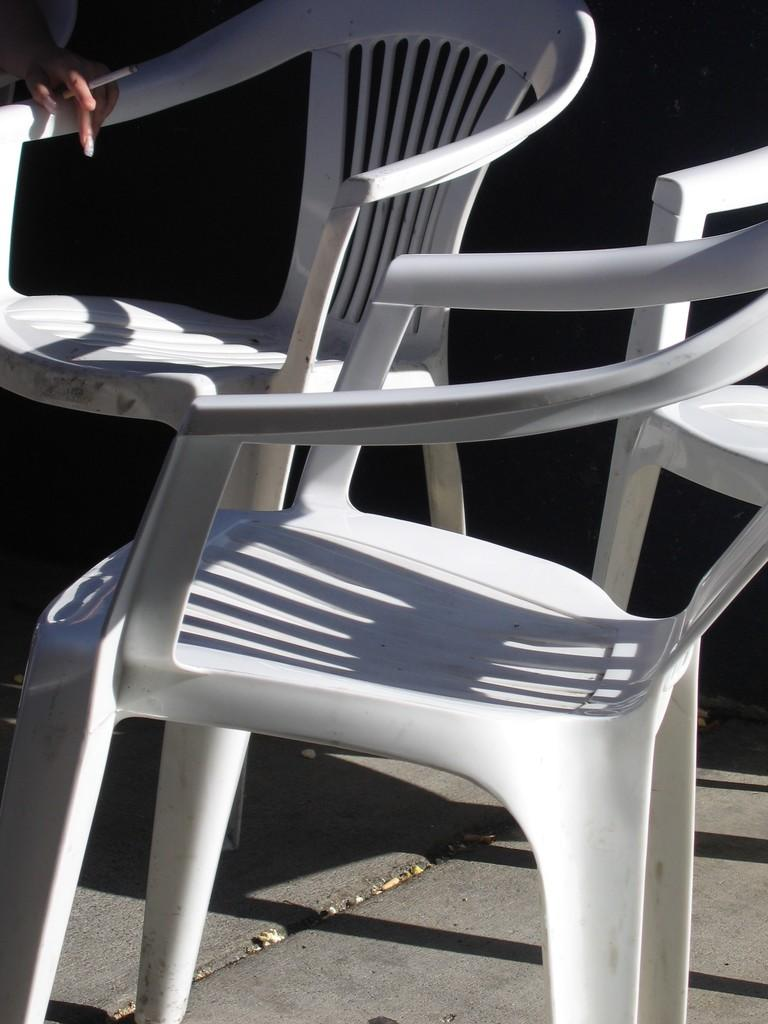What objects are on the ground in the image? There are chairs on the ground in the image. What is the person in the image doing with their hand? A person's hand is holding a cigarette in the image. Can you describe the background of the image? The background of the image is dark. Where is the girl playing in the waves in the image? There is no girl or waves present in the image; it only features chairs on the ground and a person holding a cigarette. 